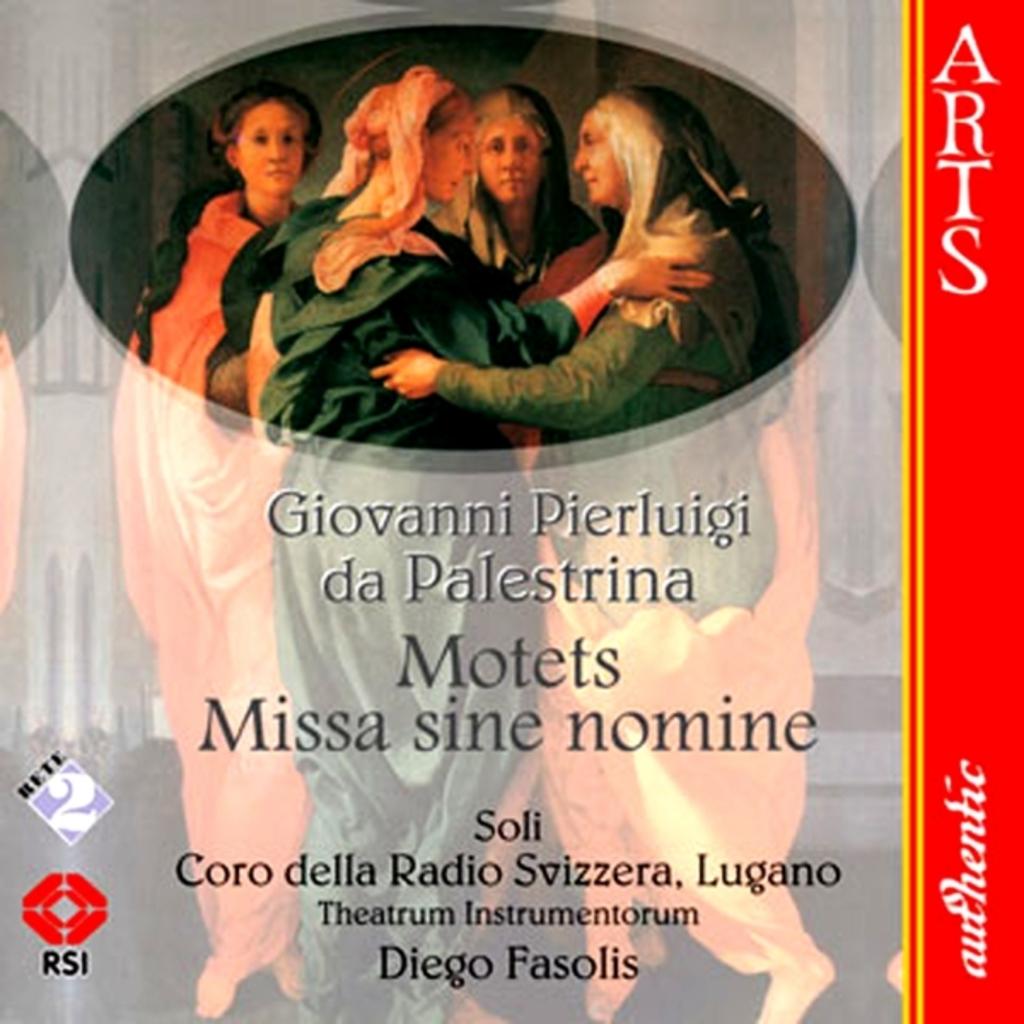What kind of performance is this regarding?
Your response must be concise. Unanswerable. Who is the man listed at the bottom of this album?
Provide a succinct answer. Diego fasolis. 